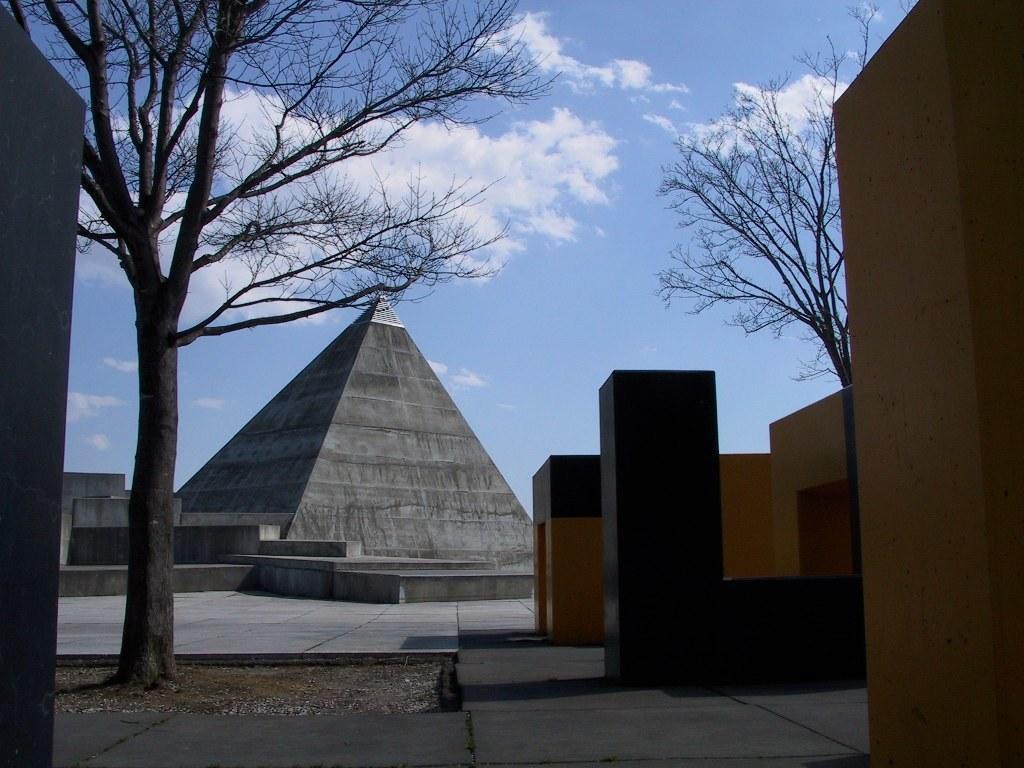Can you describe this image briefly? In this picture the object which is at back look like pyramid and this is the tree. 